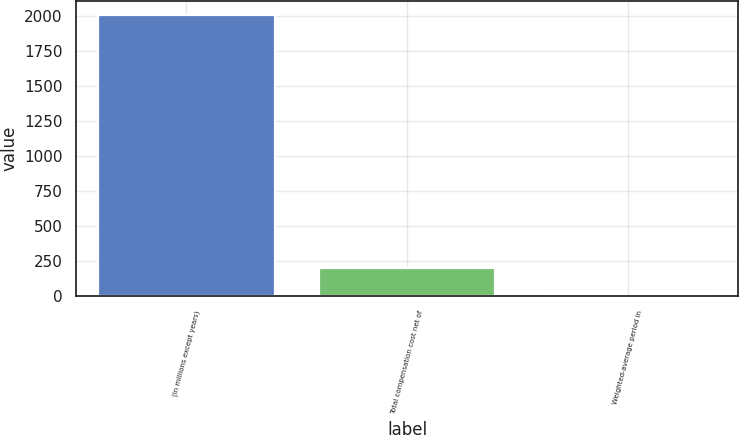<chart> <loc_0><loc_0><loc_500><loc_500><bar_chart><fcel>(in millions except years)<fcel>Total compensation cost net of<fcel>Weighted-average period in<nl><fcel>2009<fcel>202.52<fcel>1.8<nl></chart> 